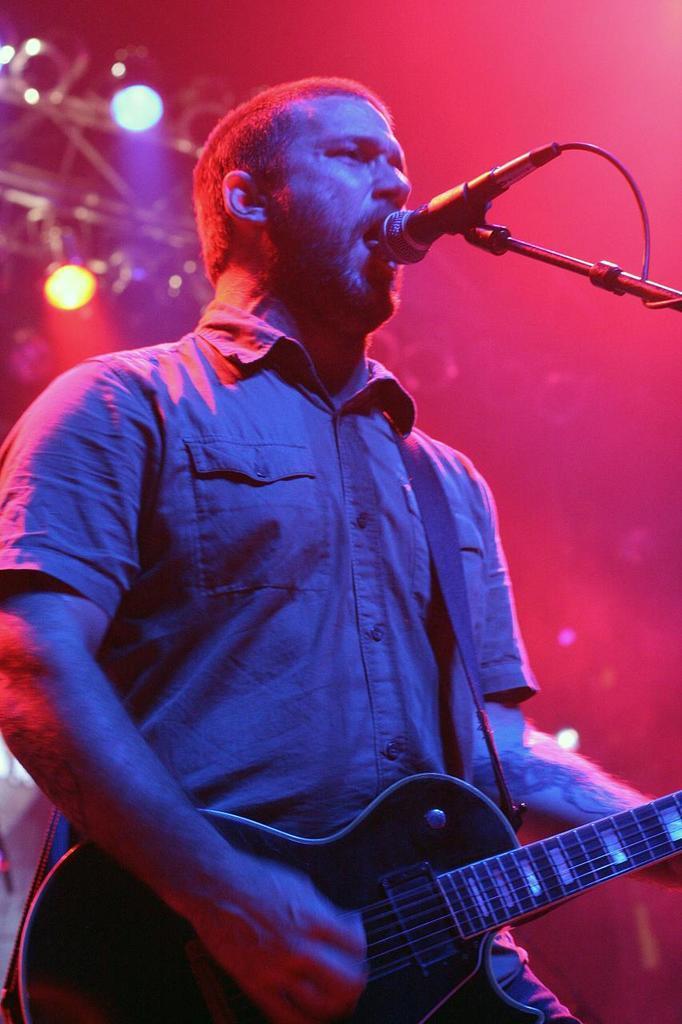How would you summarize this image in a sentence or two? In this image I can see a person standing and holding a musical instrument and singing in front of the microphone. Background I can see multi color lights. 